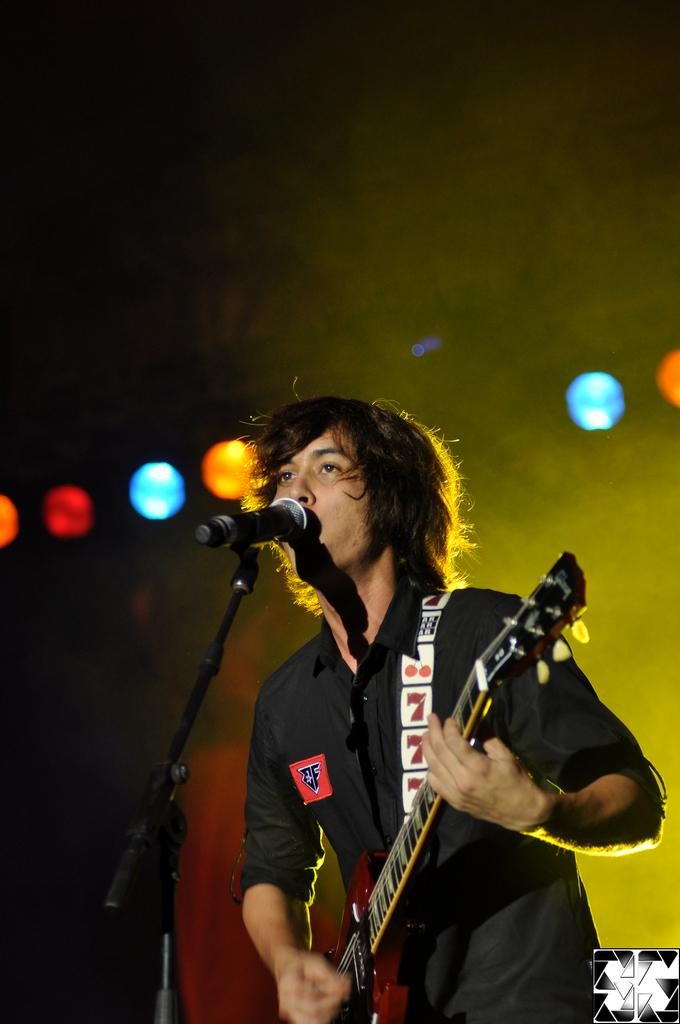What is the man in the image doing? The man is playing a guitar. How is the man positioned in the image? The man is standing. What can be seen in the background of the image? There are focus lights in the background of the image. How does the man pull sand from the guitar in the image? There is no sand present in the image, and the man is not pulling anything from the guitar. 